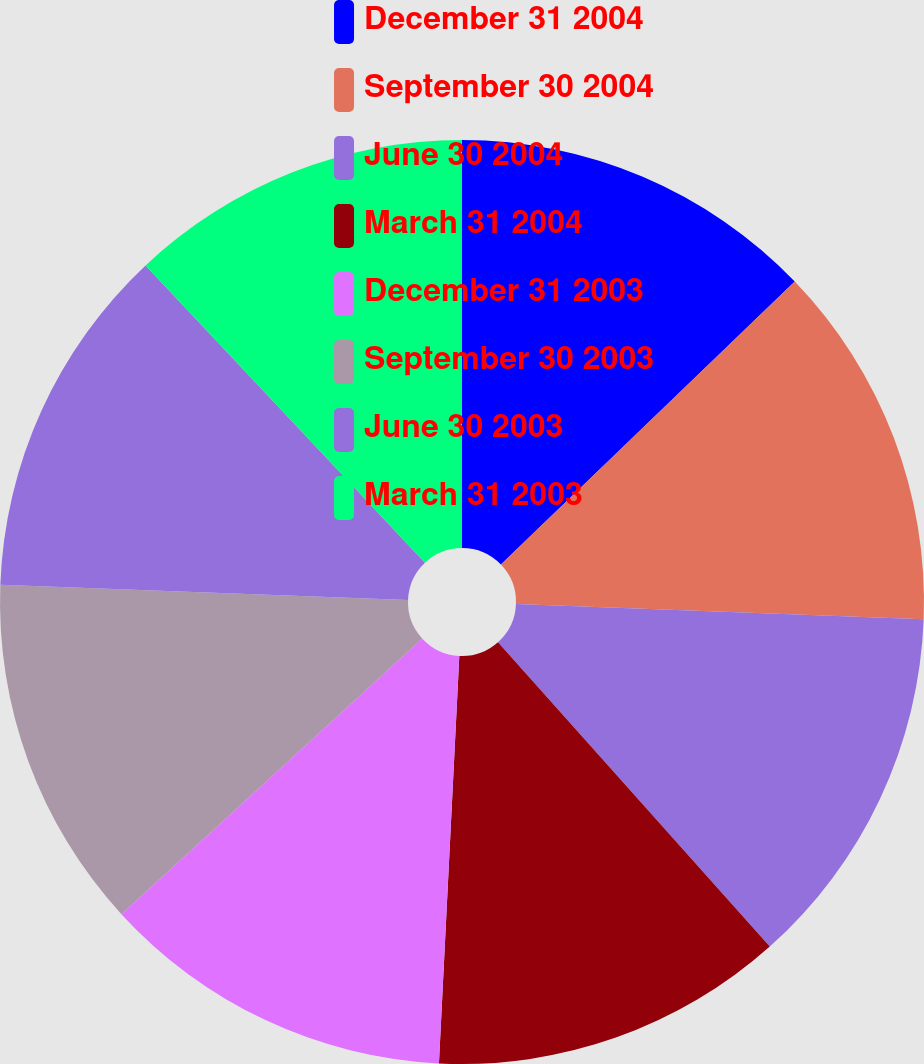<chart> <loc_0><loc_0><loc_500><loc_500><pie_chart><fcel>December 31 2004<fcel>September 30 2004<fcel>June 30 2004<fcel>March 31 2004<fcel>December 31 2003<fcel>September 30 2003<fcel>June 30 2003<fcel>March 31 2003<nl><fcel>12.8%<fcel>12.8%<fcel>12.8%<fcel>12.4%<fcel>12.4%<fcel>12.4%<fcel>12.4%<fcel>12.01%<nl></chart> 